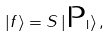<formula> <loc_0><loc_0><loc_500><loc_500>| f \rangle = S \, | \text {P} _ { \text {I} } \rangle \, ,</formula> 